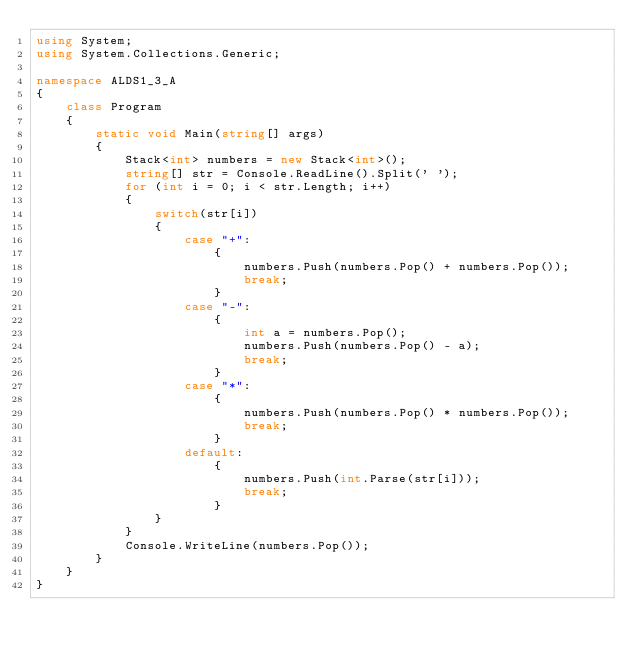Convert code to text. <code><loc_0><loc_0><loc_500><loc_500><_C#_>using System;
using System.Collections.Generic;

namespace ALDS1_3_A
{
    class Program
    {
        static void Main(string[] args)
        {
            Stack<int> numbers = new Stack<int>();
            string[] str = Console.ReadLine().Split(' ');
            for (int i = 0; i < str.Length; i++)
            {
                switch(str[i])
                {
                    case "+":
                        {
                            numbers.Push(numbers.Pop() + numbers.Pop());
                            break;
                        }
                    case "-":
                        {
                            int a = numbers.Pop();
                            numbers.Push(numbers.Pop() - a);
                            break;
                        }
                    case "*":
                        {
                            numbers.Push(numbers.Pop() * numbers.Pop());
                            break;
                        }
                    default:
                        {
                            numbers.Push(int.Parse(str[i]));
                            break;
                        }
                }
            }
            Console.WriteLine(numbers.Pop());
        }
    }
}
</code> 